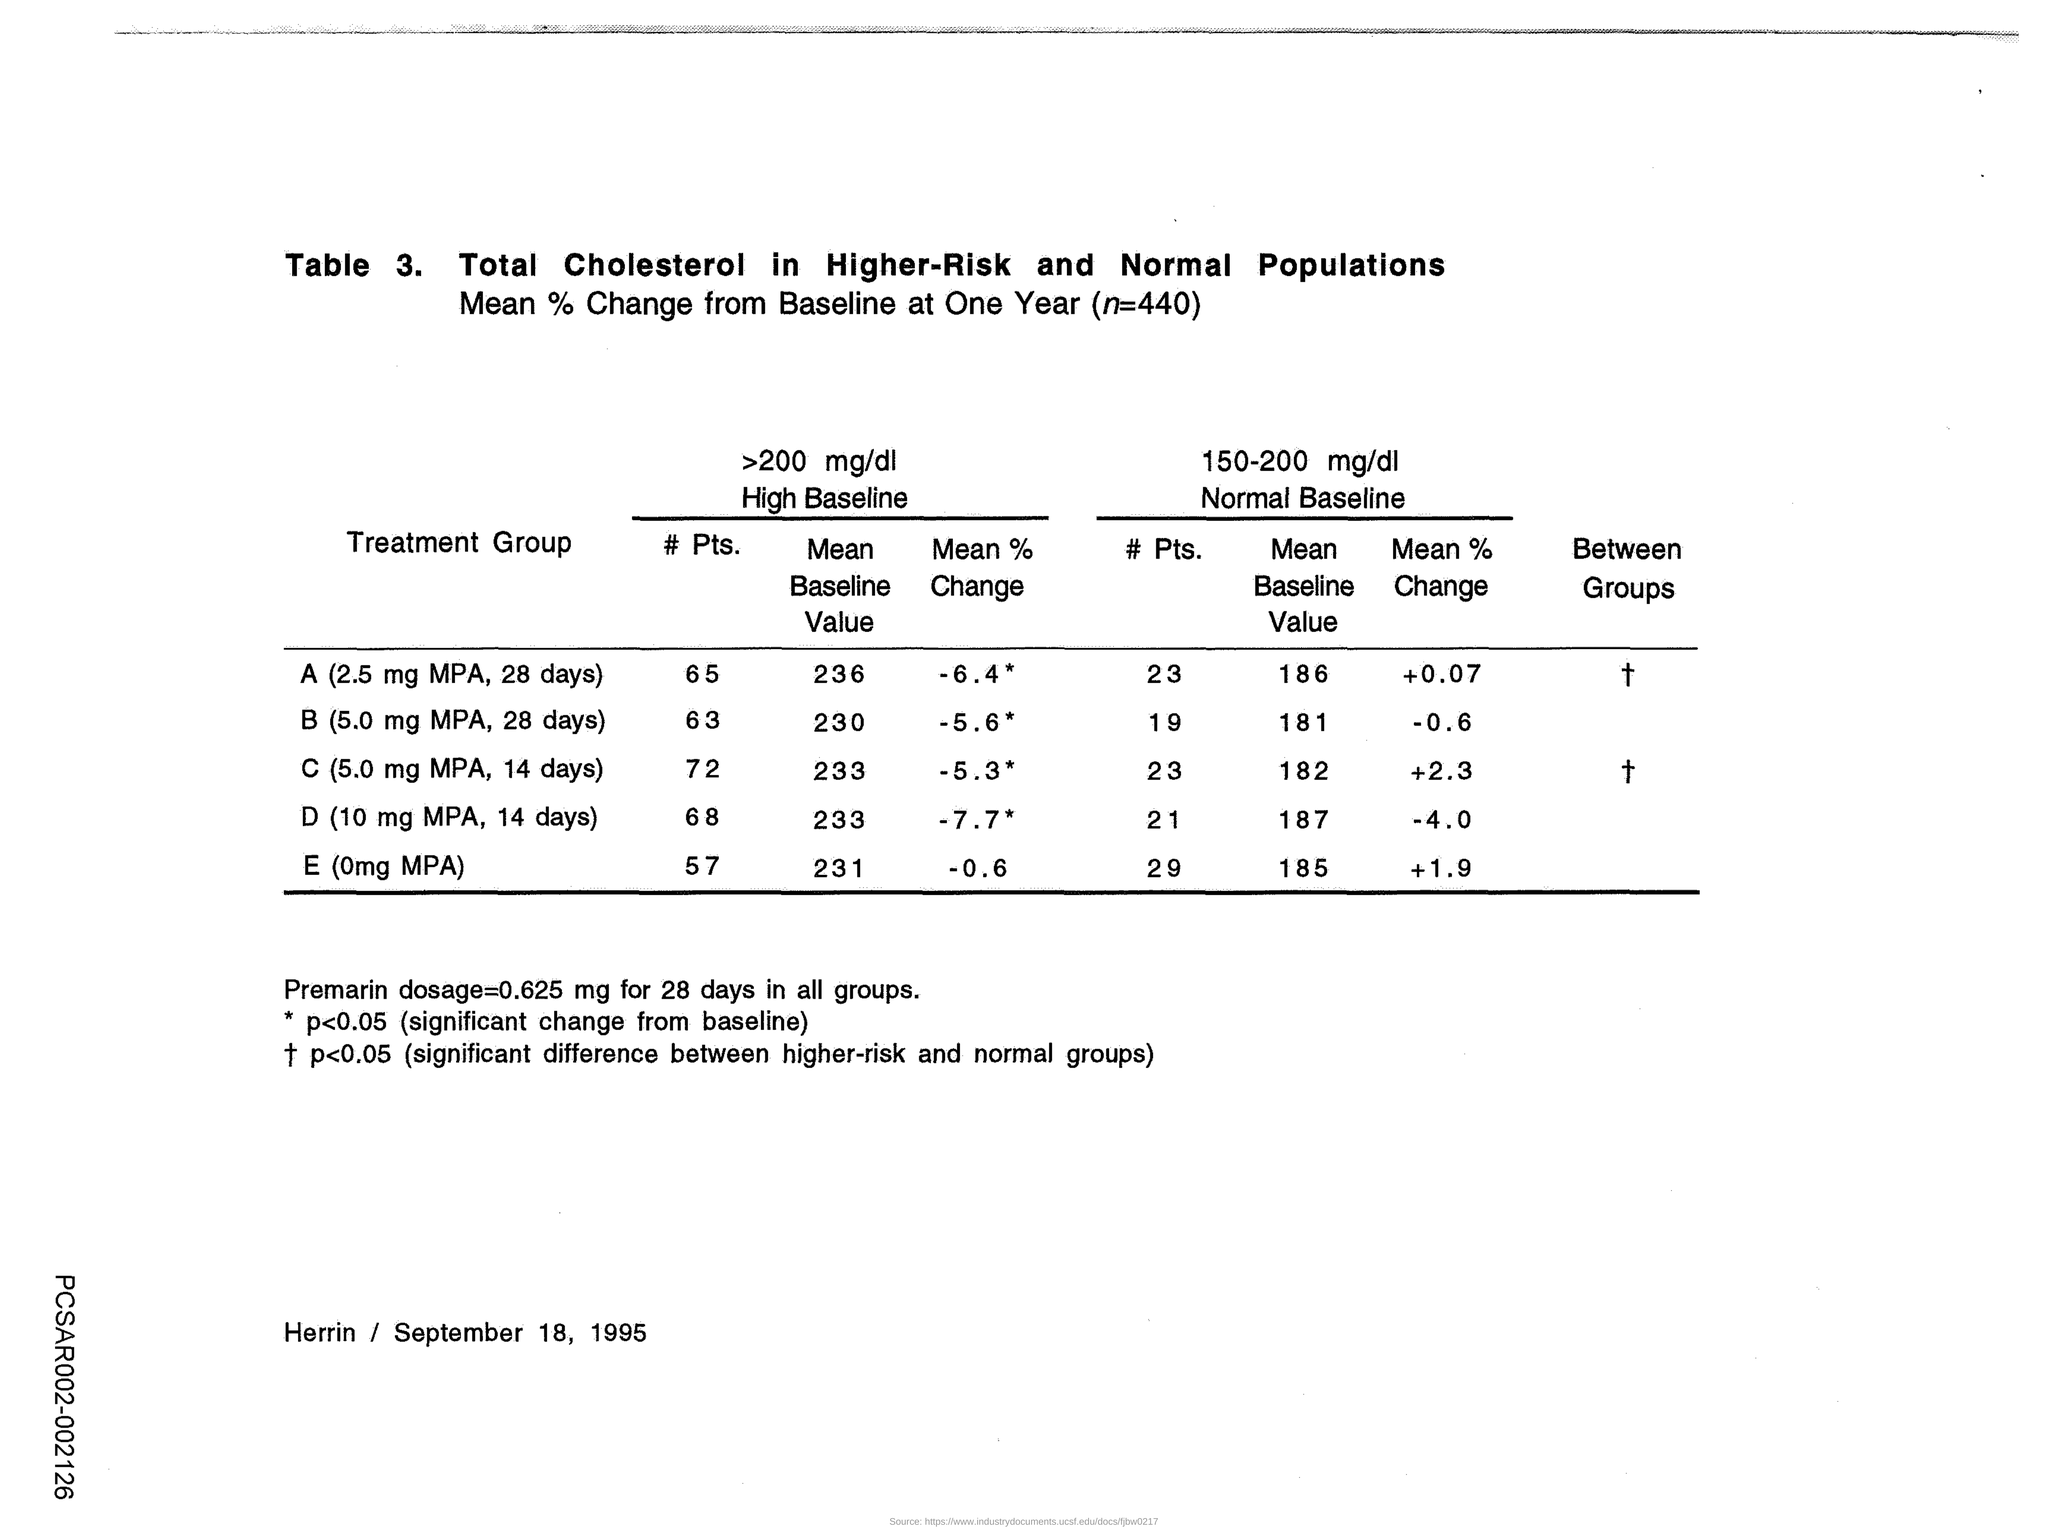Mention a couple of crucial points in this snapshot. The mean baseline value for the treatment group D is greater than 200 mg/dl. Specifically, the value is 233 mg/dl. The treatment group's baseline measurement of 200 mg/dl or higher resulted in a decrease of -6.4 to -7.7% compared to the mean percentage change for the control group. The treatment group E had a lower level of high baseline (over 200 mg/dl) compared to the control group, with a mean percentage change of -0.6%. The mean baseline value for the treatment group with a high baseline level of over 200 mg/dl is 236 mg/dl. The mean percent change in baseline for the treatment group D is -7.7% if the high baseline is greater than 200 mg/dl. 